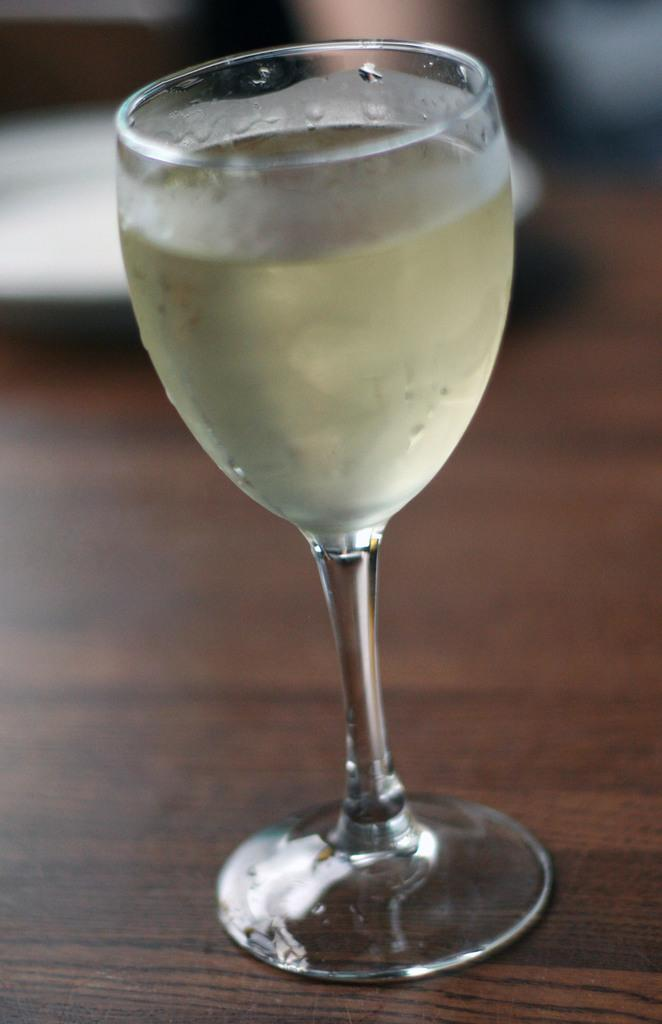What is present in the image that can hold liquid? There is a glass in the image that can hold liquid. What is inside the glass? There is liquid in the glass. Where is the glass located? The glass is on a table. What is the color of the table? The table is brown in color. What type of zephyr is being played on the guitar in the image? There is no guitar or zephyr present in the image. What kind of pie is being served on the table in the image? There is no pie present in the image; it only features a glass with liquid on a brown table. 